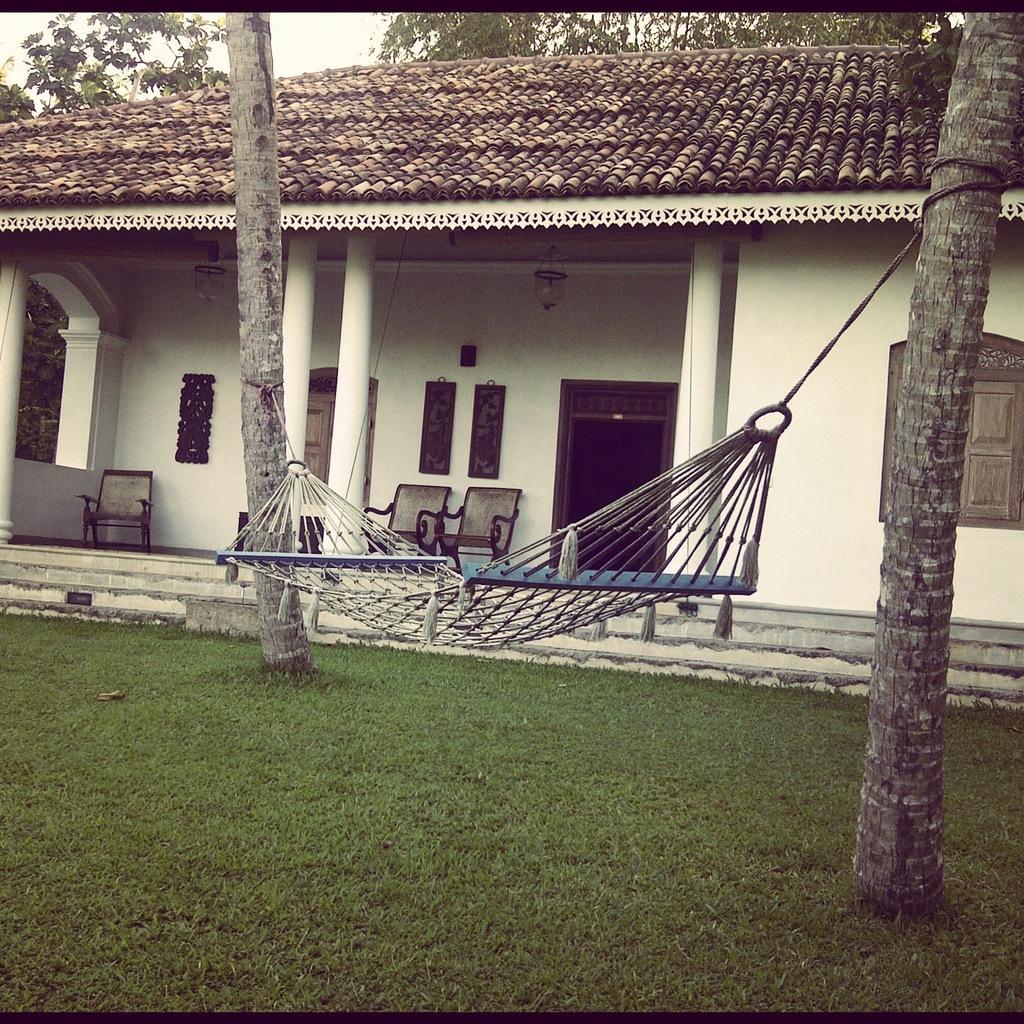Describe this image in one or two sentences. In this image there is a mesh swing, trees, houses, chairs, boards, grass, sky, pillars and objects. 